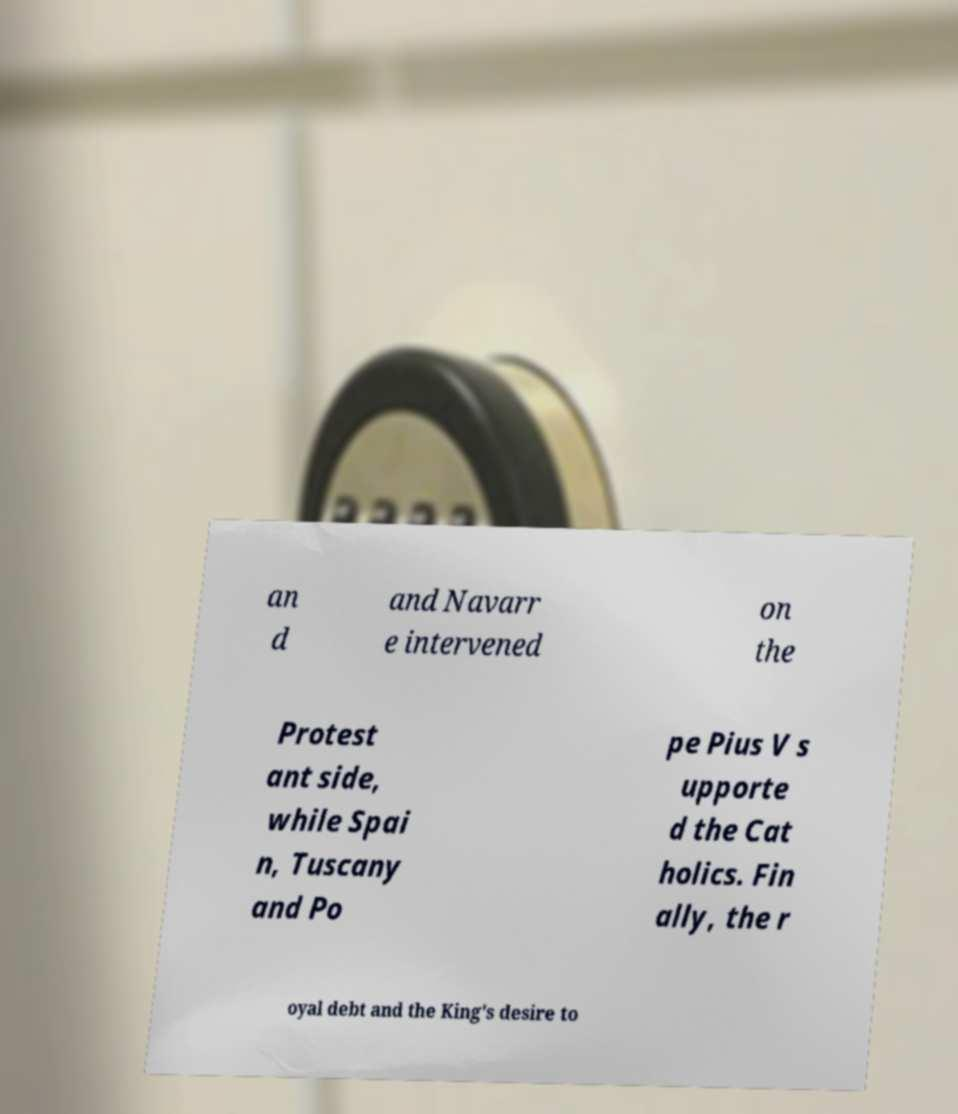I need the written content from this picture converted into text. Can you do that? an d and Navarr e intervened on the Protest ant side, while Spai n, Tuscany and Po pe Pius V s upporte d the Cat holics. Fin ally, the r oyal debt and the King's desire to 